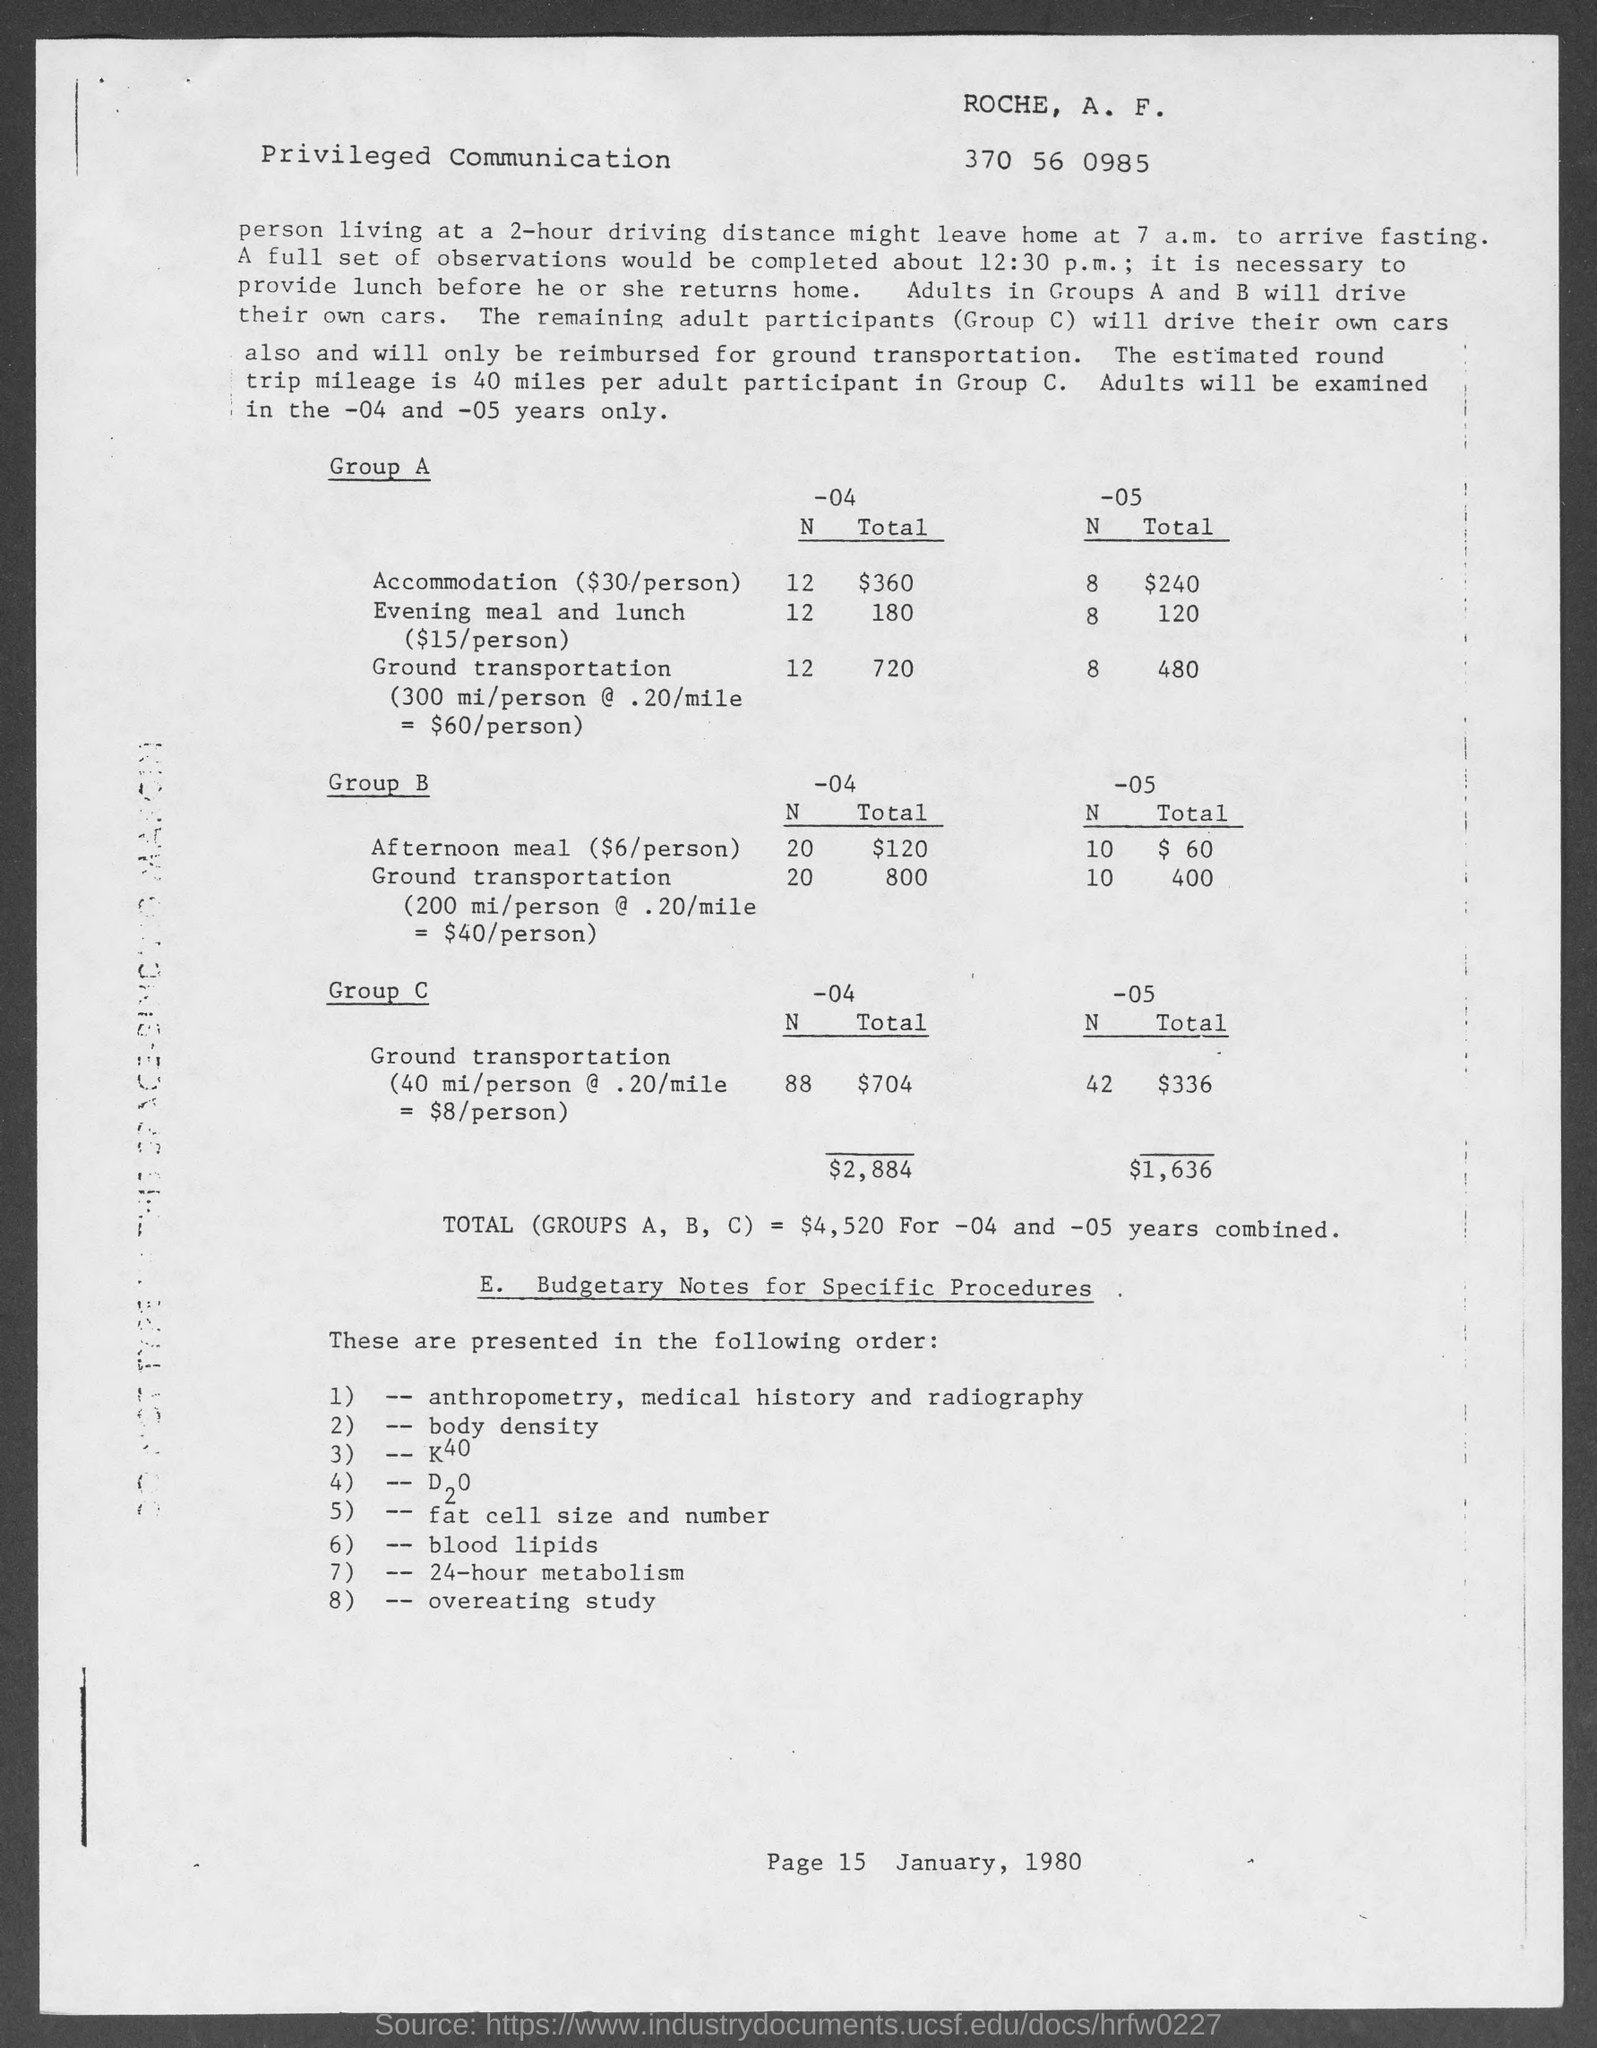What is the date mentioned in the document?
Provide a short and direct response. January, 1980. What is the page number?
Offer a terse response. Page 15. 